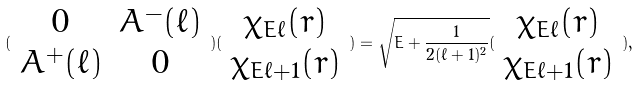Convert formula to latex. <formula><loc_0><loc_0><loc_500><loc_500>( \begin{array} { c c } 0 & A ^ { - } ( \ell ) \\ A ^ { + } ( \ell ) & 0 \end{array} ) ( \begin{array} { c } \chi _ { E \ell } ( r ) \\ \chi _ { E \ell + 1 } ( r ) \end{array} ) = \sqrt { E + \frac { 1 } { 2 ( \ell + 1 ) ^ { 2 } } } ( \begin{array} { c } \chi _ { E \ell } ( r ) \\ \chi _ { E \ell + 1 } ( r ) \end{array} ) ,</formula> 